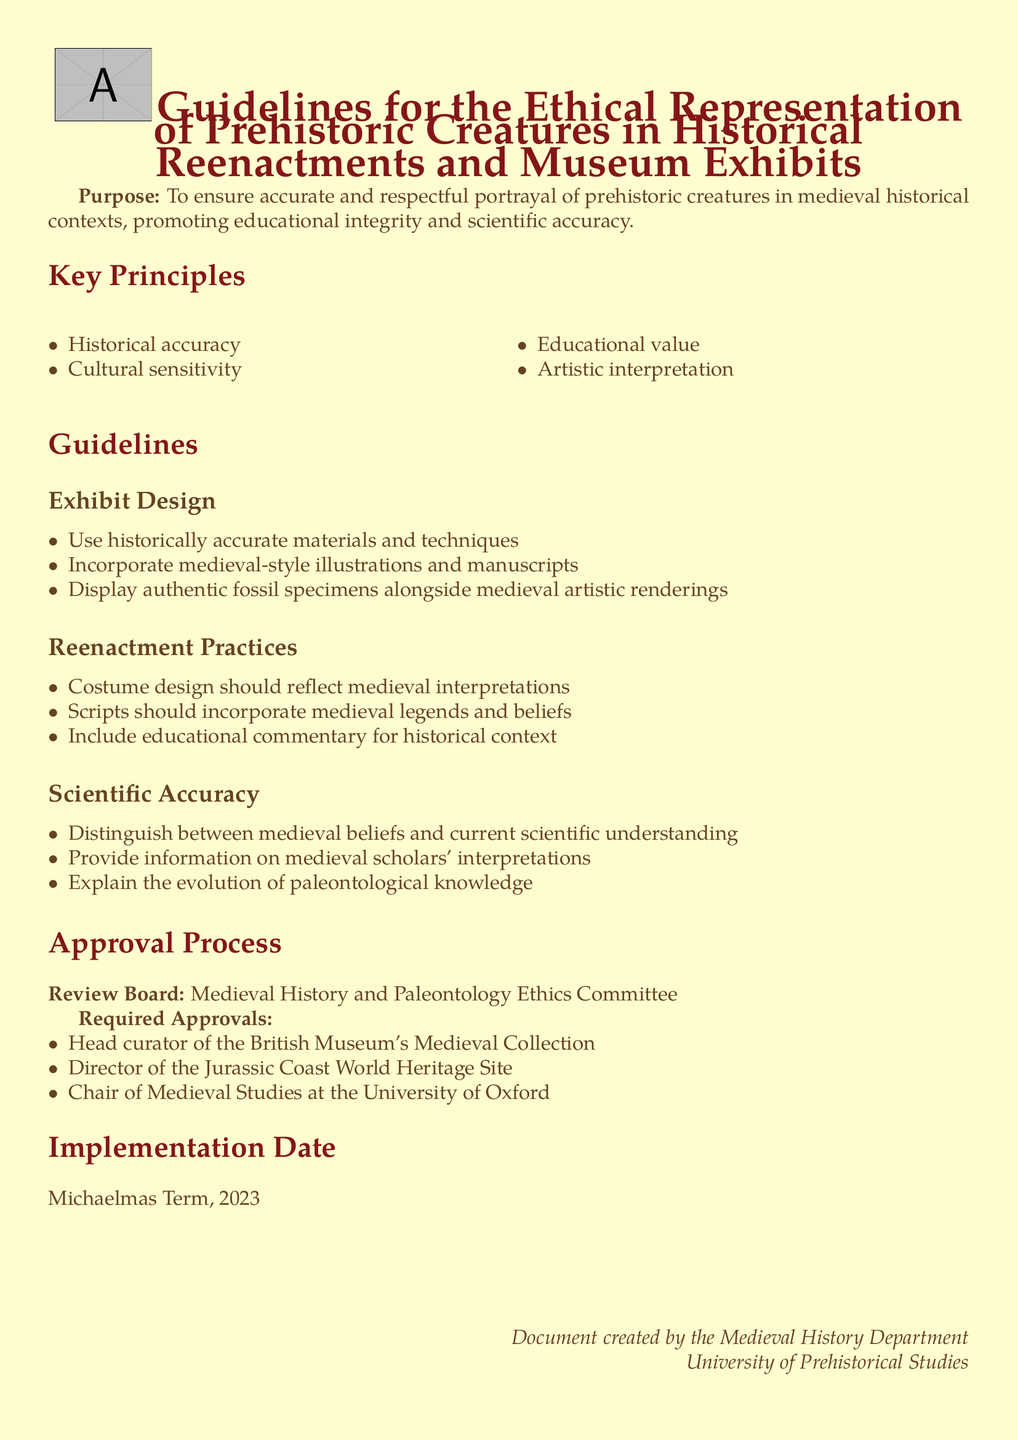What is the purpose of the guidelines? The purpose is to ensure accurate and respectful portrayal of prehistoric creatures in medieval historical contexts, promoting educational integrity and scientific accuracy.
Answer: To ensure accurate and respectful portrayal of prehistoric creatures in medieval historical contexts, promoting educational integrity and scientific accuracy Who created the document? The document is created by the Medieval History Department of the University of Prehistorical Studies.
Answer: Medieval History Department What term is the implementation date set for? The implementation date is specified as the Michaelmas Term of 2023.
Answer: Michaelmas Term, 2023 Which body must approve the guidelines? The review board specified in the document is the Medieval History and Paleontology Ethics Committee.
Answer: Medieval History and Paleontology Ethics Committee What should exhibit design incorporate? Exhibit design should incorporate medieval-style illustrations and manuscripts.
Answer: Medieval-style illustrations and manuscripts How many required approvals are mentioned? The document mentions three required approvals from specified authorities.
Answer: Three What is one key principle highlighted in the document? Historical accuracy is one of the key principles emphasized.
Answer: Historical accuracy What type of commentary should be included in reenactments? Educational commentary for historical context should be included in reenactments.
Answer: Educational commentary for historical context What distinguishes between medieval beliefs and current understanding? The guidelines request to distinguish between medieval beliefs and current scientific understanding.
Answer: Distinguish between medieval beliefs and current scientific understanding 